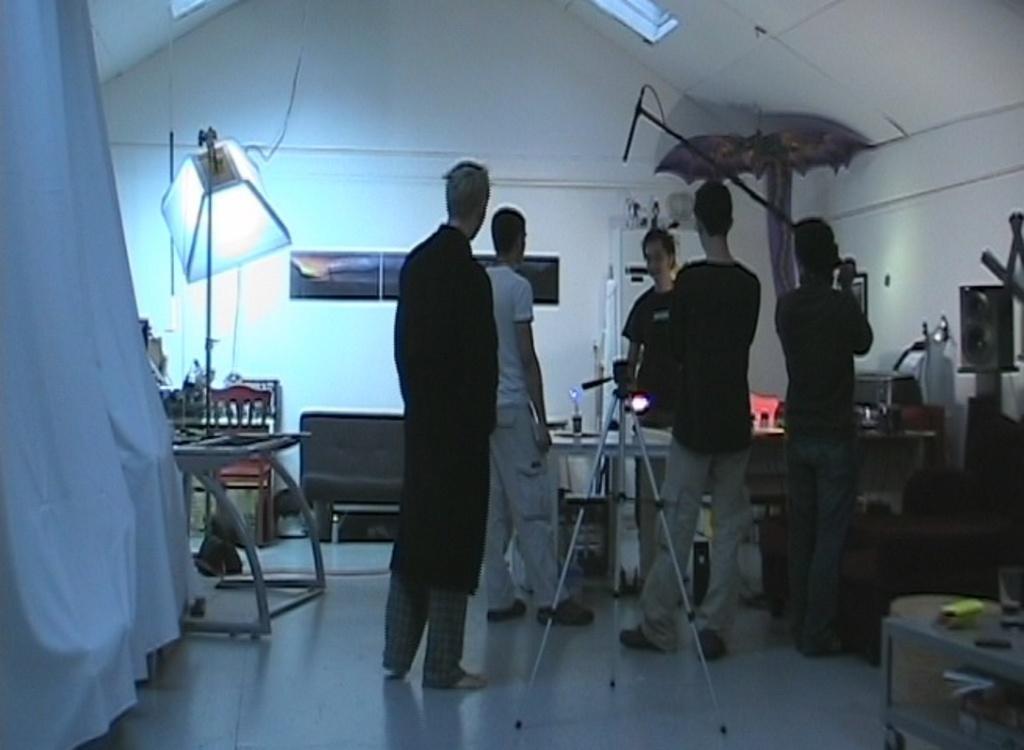In one or two sentences, can you explain what this image depicts? The image is taken in a room. In the center of the picture there are people, stands, table, mic and other objects. On the left there are chair, tables, curtain, light, cable and other objects. On the right there are tables and other objects. In the center of the background there are frames and a couch. 